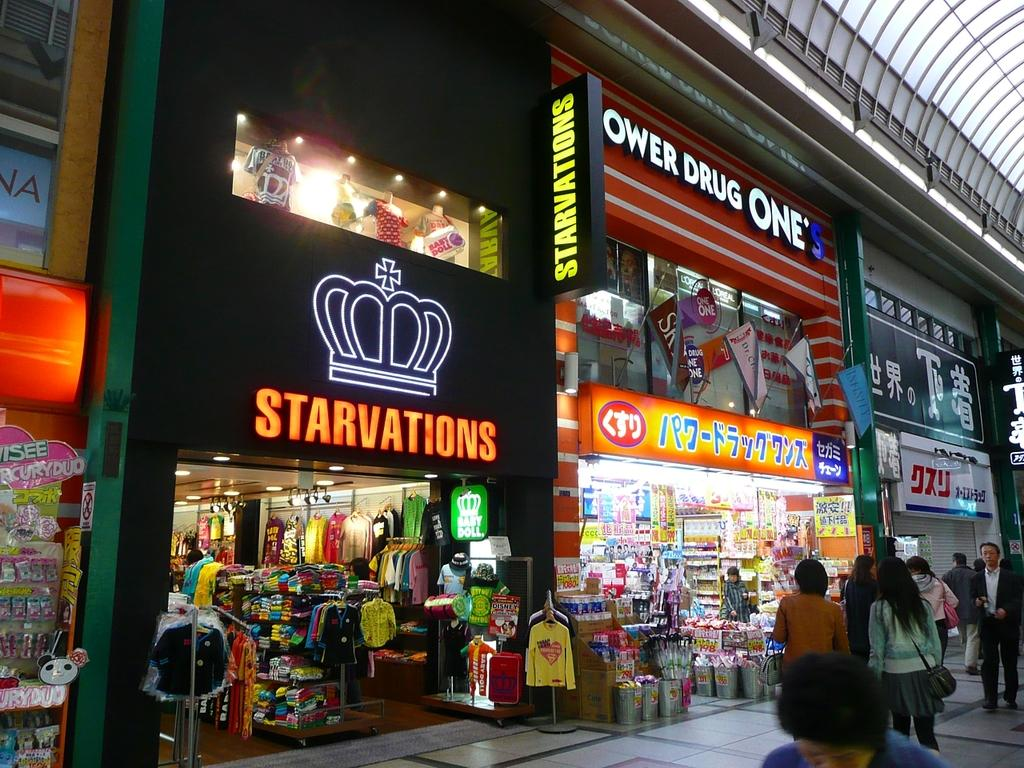<image>
Relay a brief, clear account of the picture shown. Shoppers on a street are shown in front of stores such as Starvations and Ower Drug One's. 